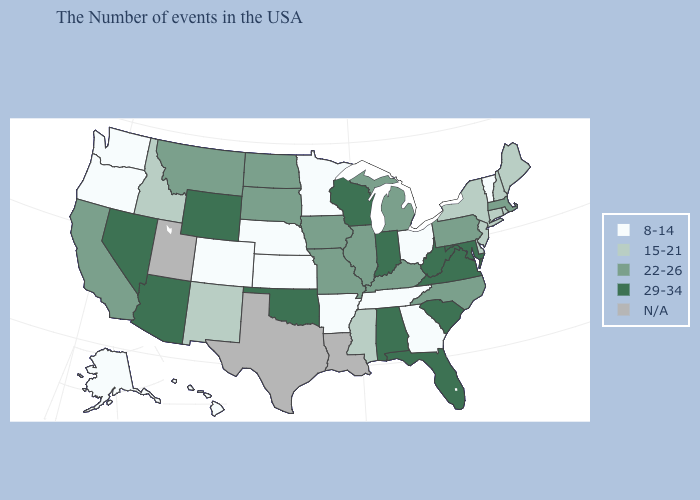Which states have the lowest value in the USA?
Answer briefly. Vermont, Ohio, Georgia, Tennessee, Arkansas, Minnesota, Kansas, Nebraska, Colorado, Washington, Oregon, Alaska, Hawaii. What is the value of North Dakota?
Write a very short answer. 22-26. What is the value of New Mexico?
Be succinct. 15-21. What is the highest value in the USA?
Keep it brief. 29-34. Among the states that border Iowa , does Nebraska have the lowest value?
Write a very short answer. Yes. Name the states that have a value in the range N/A?
Short answer required. Louisiana, Texas, Utah. Name the states that have a value in the range 22-26?
Be succinct. Massachusetts, Pennsylvania, North Carolina, Michigan, Kentucky, Illinois, Missouri, Iowa, South Dakota, North Dakota, Montana, California. What is the value of Florida?
Answer briefly. 29-34. What is the value of Indiana?
Be succinct. 29-34. Does New York have the highest value in the Northeast?
Write a very short answer. No. Does Florida have the highest value in the USA?
Write a very short answer. Yes. What is the lowest value in the USA?
Answer briefly. 8-14. What is the value of South Dakota?
Quick response, please. 22-26. Name the states that have a value in the range 29-34?
Quick response, please. Maryland, Virginia, South Carolina, West Virginia, Florida, Indiana, Alabama, Wisconsin, Oklahoma, Wyoming, Arizona, Nevada. 